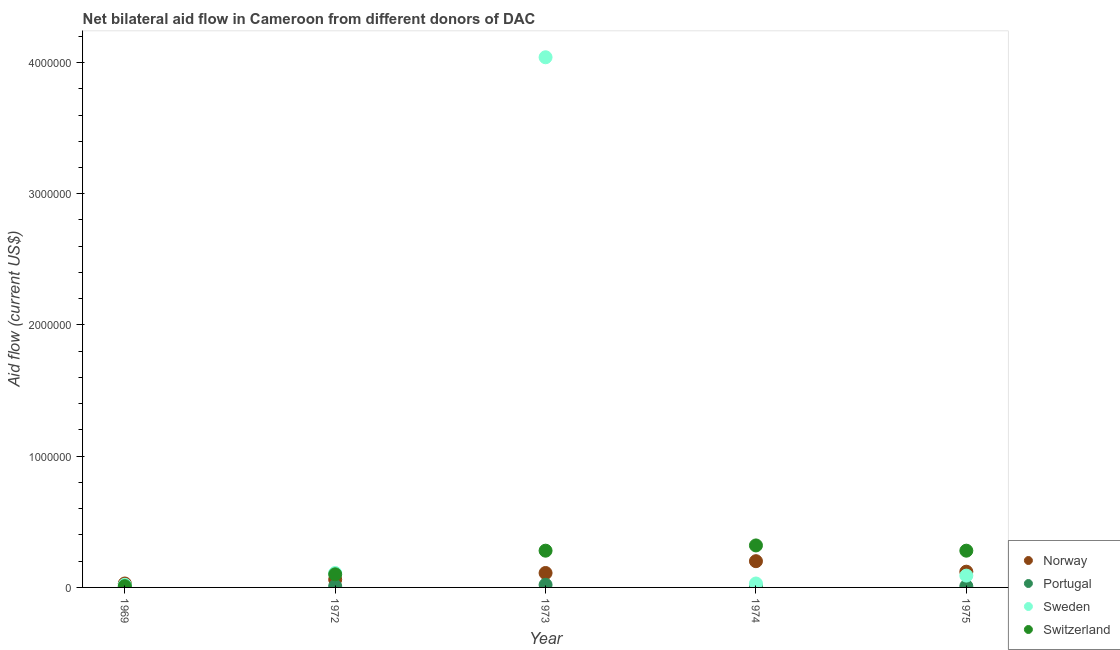How many different coloured dotlines are there?
Your answer should be compact. 4. What is the amount of aid given by norway in 1975?
Keep it short and to the point. 1.20e+05. Across all years, what is the maximum amount of aid given by switzerland?
Provide a short and direct response. 3.20e+05. Across all years, what is the minimum amount of aid given by portugal?
Your answer should be compact. 10000. In which year was the amount of aid given by norway maximum?
Ensure brevity in your answer.  1974. In which year was the amount of aid given by sweden minimum?
Give a very brief answer. 1969. What is the total amount of aid given by sweden in the graph?
Give a very brief answer. 4.29e+06. What is the difference between the amount of aid given by switzerland in 1969 and that in 1974?
Make the answer very short. -3.10e+05. What is the difference between the amount of aid given by sweden in 1975 and the amount of aid given by switzerland in 1972?
Offer a very short reply. -10000. What is the average amount of aid given by norway per year?
Ensure brevity in your answer.  1.04e+05. In the year 1969, what is the difference between the amount of aid given by portugal and amount of aid given by sweden?
Give a very brief answer. -10000. In how many years, is the amount of aid given by sweden greater than 2600000 US$?
Provide a succinct answer. 1. What is the ratio of the amount of aid given by sweden in 1969 to that in 1973?
Your answer should be compact. 0. Is the amount of aid given by portugal in 1972 less than that in 1975?
Your response must be concise. No. What is the difference between the highest and the lowest amount of aid given by portugal?
Offer a terse response. 10000. In how many years, is the amount of aid given by switzerland greater than the average amount of aid given by switzerland taken over all years?
Offer a very short reply. 3. Is the sum of the amount of aid given by portugal in 1972 and 1973 greater than the maximum amount of aid given by sweden across all years?
Ensure brevity in your answer.  No. Is the amount of aid given by switzerland strictly less than the amount of aid given by sweden over the years?
Offer a terse response. No. Does the graph contain grids?
Make the answer very short. No. How many legend labels are there?
Ensure brevity in your answer.  4. How are the legend labels stacked?
Your answer should be very brief. Vertical. What is the title of the graph?
Provide a succinct answer. Net bilateral aid flow in Cameroon from different donors of DAC. Does "Macroeconomic management" appear as one of the legend labels in the graph?
Offer a terse response. No. What is the label or title of the Y-axis?
Your response must be concise. Aid flow (current US$). What is the Aid flow (current US$) in Norway in 1972?
Your answer should be very brief. 6.00e+04. What is the Aid flow (current US$) in Sweden in 1973?
Your answer should be compact. 4.04e+06. What is the Aid flow (current US$) in Switzerland in 1974?
Give a very brief answer. 3.20e+05. What is the Aid flow (current US$) of Portugal in 1975?
Your answer should be compact. 10000. What is the Aid flow (current US$) of Sweden in 1975?
Your answer should be very brief. 9.00e+04. Across all years, what is the maximum Aid flow (current US$) of Norway?
Keep it short and to the point. 2.00e+05. Across all years, what is the maximum Aid flow (current US$) of Sweden?
Provide a short and direct response. 4.04e+06. Across all years, what is the maximum Aid flow (current US$) in Switzerland?
Your answer should be compact. 3.20e+05. Across all years, what is the minimum Aid flow (current US$) in Norway?
Your response must be concise. 3.00e+04. Across all years, what is the minimum Aid flow (current US$) in Switzerland?
Ensure brevity in your answer.  10000. What is the total Aid flow (current US$) in Norway in the graph?
Keep it short and to the point. 5.20e+05. What is the total Aid flow (current US$) in Sweden in the graph?
Your response must be concise. 4.29e+06. What is the total Aid flow (current US$) of Switzerland in the graph?
Ensure brevity in your answer.  9.90e+05. What is the difference between the Aid flow (current US$) in Norway in 1969 and that in 1972?
Your answer should be compact. -3.00e+04. What is the difference between the Aid flow (current US$) of Portugal in 1969 and that in 1972?
Ensure brevity in your answer.  0. What is the difference between the Aid flow (current US$) of Sweden in 1969 and that in 1972?
Ensure brevity in your answer.  -9.00e+04. What is the difference between the Aid flow (current US$) in Norway in 1969 and that in 1973?
Offer a very short reply. -8.00e+04. What is the difference between the Aid flow (current US$) in Sweden in 1969 and that in 1973?
Ensure brevity in your answer.  -4.02e+06. What is the difference between the Aid flow (current US$) in Switzerland in 1969 and that in 1974?
Your answer should be very brief. -3.10e+05. What is the difference between the Aid flow (current US$) in Portugal in 1969 and that in 1975?
Provide a short and direct response. 0. What is the difference between the Aid flow (current US$) in Norway in 1972 and that in 1973?
Your answer should be compact. -5.00e+04. What is the difference between the Aid flow (current US$) in Sweden in 1972 and that in 1973?
Keep it short and to the point. -3.93e+06. What is the difference between the Aid flow (current US$) in Switzerland in 1972 and that in 1973?
Your response must be concise. -1.80e+05. What is the difference between the Aid flow (current US$) in Portugal in 1972 and that in 1974?
Give a very brief answer. 0. What is the difference between the Aid flow (current US$) of Sweden in 1972 and that in 1974?
Your answer should be very brief. 8.00e+04. What is the difference between the Aid flow (current US$) in Switzerland in 1972 and that in 1974?
Offer a terse response. -2.20e+05. What is the difference between the Aid flow (current US$) of Norway in 1973 and that in 1974?
Give a very brief answer. -9.00e+04. What is the difference between the Aid flow (current US$) in Sweden in 1973 and that in 1974?
Your answer should be very brief. 4.01e+06. What is the difference between the Aid flow (current US$) of Portugal in 1973 and that in 1975?
Keep it short and to the point. 10000. What is the difference between the Aid flow (current US$) of Sweden in 1973 and that in 1975?
Your response must be concise. 3.95e+06. What is the difference between the Aid flow (current US$) in Sweden in 1974 and that in 1975?
Provide a succinct answer. -6.00e+04. What is the difference between the Aid flow (current US$) of Norway in 1969 and the Aid flow (current US$) of Sweden in 1972?
Keep it short and to the point. -8.00e+04. What is the difference between the Aid flow (current US$) of Norway in 1969 and the Aid flow (current US$) of Switzerland in 1972?
Provide a succinct answer. -7.00e+04. What is the difference between the Aid flow (current US$) of Norway in 1969 and the Aid flow (current US$) of Sweden in 1973?
Provide a succinct answer. -4.01e+06. What is the difference between the Aid flow (current US$) in Norway in 1969 and the Aid flow (current US$) in Switzerland in 1973?
Your response must be concise. -2.50e+05. What is the difference between the Aid flow (current US$) in Portugal in 1969 and the Aid flow (current US$) in Sweden in 1973?
Keep it short and to the point. -4.03e+06. What is the difference between the Aid flow (current US$) in Norway in 1969 and the Aid flow (current US$) in Portugal in 1974?
Keep it short and to the point. 2.00e+04. What is the difference between the Aid flow (current US$) in Norway in 1969 and the Aid flow (current US$) in Sweden in 1974?
Give a very brief answer. 0. What is the difference between the Aid flow (current US$) of Portugal in 1969 and the Aid flow (current US$) of Switzerland in 1974?
Provide a succinct answer. -3.10e+05. What is the difference between the Aid flow (current US$) in Sweden in 1969 and the Aid flow (current US$) in Switzerland in 1974?
Provide a short and direct response. -3.00e+05. What is the difference between the Aid flow (current US$) in Norway in 1969 and the Aid flow (current US$) in Switzerland in 1975?
Offer a very short reply. -2.50e+05. What is the difference between the Aid flow (current US$) in Portugal in 1969 and the Aid flow (current US$) in Sweden in 1975?
Your response must be concise. -8.00e+04. What is the difference between the Aid flow (current US$) in Portugal in 1969 and the Aid flow (current US$) in Switzerland in 1975?
Offer a very short reply. -2.70e+05. What is the difference between the Aid flow (current US$) in Sweden in 1969 and the Aid flow (current US$) in Switzerland in 1975?
Make the answer very short. -2.60e+05. What is the difference between the Aid flow (current US$) of Norway in 1972 and the Aid flow (current US$) of Sweden in 1973?
Keep it short and to the point. -3.98e+06. What is the difference between the Aid flow (current US$) of Norway in 1972 and the Aid flow (current US$) of Switzerland in 1973?
Provide a succinct answer. -2.20e+05. What is the difference between the Aid flow (current US$) of Portugal in 1972 and the Aid flow (current US$) of Sweden in 1973?
Give a very brief answer. -4.03e+06. What is the difference between the Aid flow (current US$) of Portugal in 1972 and the Aid flow (current US$) of Switzerland in 1973?
Offer a terse response. -2.70e+05. What is the difference between the Aid flow (current US$) in Norway in 1972 and the Aid flow (current US$) in Sweden in 1974?
Ensure brevity in your answer.  3.00e+04. What is the difference between the Aid flow (current US$) of Norway in 1972 and the Aid flow (current US$) of Switzerland in 1974?
Provide a succinct answer. -2.60e+05. What is the difference between the Aid flow (current US$) in Portugal in 1972 and the Aid flow (current US$) in Switzerland in 1974?
Your response must be concise. -3.10e+05. What is the difference between the Aid flow (current US$) in Portugal in 1972 and the Aid flow (current US$) in Sweden in 1975?
Make the answer very short. -8.00e+04. What is the difference between the Aid flow (current US$) in Sweden in 1972 and the Aid flow (current US$) in Switzerland in 1975?
Provide a succinct answer. -1.70e+05. What is the difference between the Aid flow (current US$) in Sweden in 1973 and the Aid flow (current US$) in Switzerland in 1974?
Your answer should be compact. 3.72e+06. What is the difference between the Aid flow (current US$) in Portugal in 1973 and the Aid flow (current US$) in Switzerland in 1975?
Give a very brief answer. -2.60e+05. What is the difference between the Aid flow (current US$) of Sweden in 1973 and the Aid flow (current US$) of Switzerland in 1975?
Provide a succinct answer. 3.76e+06. What is the difference between the Aid flow (current US$) in Norway in 1974 and the Aid flow (current US$) in Portugal in 1975?
Provide a succinct answer. 1.90e+05. What is the difference between the Aid flow (current US$) in Norway in 1974 and the Aid flow (current US$) in Switzerland in 1975?
Your answer should be very brief. -8.00e+04. What is the difference between the Aid flow (current US$) in Portugal in 1974 and the Aid flow (current US$) in Sweden in 1975?
Provide a short and direct response. -8.00e+04. What is the difference between the Aid flow (current US$) in Portugal in 1974 and the Aid flow (current US$) in Switzerland in 1975?
Provide a short and direct response. -2.70e+05. What is the average Aid flow (current US$) of Norway per year?
Your answer should be very brief. 1.04e+05. What is the average Aid flow (current US$) of Portugal per year?
Your answer should be very brief. 1.20e+04. What is the average Aid flow (current US$) in Sweden per year?
Offer a very short reply. 8.58e+05. What is the average Aid flow (current US$) of Switzerland per year?
Keep it short and to the point. 1.98e+05. In the year 1969, what is the difference between the Aid flow (current US$) in Norway and Aid flow (current US$) in Portugal?
Your answer should be compact. 2.00e+04. In the year 1969, what is the difference between the Aid flow (current US$) of Portugal and Aid flow (current US$) of Sweden?
Provide a succinct answer. -10000. In the year 1969, what is the difference between the Aid flow (current US$) in Portugal and Aid flow (current US$) in Switzerland?
Keep it short and to the point. 0. In the year 1969, what is the difference between the Aid flow (current US$) in Sweden and Aid flow (current US$) in Switzerland?
Keep it short and to the point. 10000. In the year 1972, what is the difference between the Aid flow (current US$) of Norway and Aid flow (current US$) of Portugal?
Your response must be concise. 5.00e+04. In the year 1972, what is the difference between the Aid flow (current US$) of Norway and Aid flow (current US$) of Switzerland?
Your answer should be very brief. -4.00e+04. In the year 1972, what is the difference between the Aid flow (current US$) of Portugal and Aid flow (current US$) of Sweden?
Provide a short and direct response. -1.00e+05. In the year 1972, what is the difference between the Aid flow (current US$) of Portugal and Aid flow (current US$) of Switzerland?
Provide a short and direct response. -9.00e+04. In the year 1973, what is the difference between the Aid flow (current US$) in Norway and Aid flow (current US$) in Portugal?
Offer a terse response. 9.00e+04. In the year 1973, what is the difference between the Aid flow (current US$) of Norway and Aid flow (current US$) of Sweden?
Make the answer very short. -3.93e+06. In the year 1973, what is the difference between the Aid flow (current US$) in Portugal and Aid flow (current US$) in Sweden?
Make the answer very short. -4.02e+06. In the year 1973, what is the difference between the Aid flow (current US$) in Portugal and Aid flow (current US$) in Switzerland?
Offer a terse response. -2.60e+05. In the year 1973, what is the difference between the Aid flow (current US$) of Sweden and Aid flow (current US$) of Switzerland?
Give a very brief answer. 3.76e+06. In the year 1974, what is the difference between the Aid flow (current US$) in Norway and Aid flow (current US$) in Portugal?
Keep it short and to the point. 1.90e+05. In the year 1974, what is the difference between the Aid flow (current US$) of Portugal and Aid flow (current US$) of Sweden?
Ensure brevity in your answer.  -2.00e+04. In the year 1974, what is the difference between the Aid flow (current US$) in Portugal and Aid flow (current US$) in Switzerland?
Your answer should be compact. -3.10e+05. In the year 1974, what is the difference between the Aid flow (current US$) of Sweden and Aid flow (current US$) of Switzerland?
Your response must be concise. -2.90e+05. In the year 1975, what is the difference between the Aid flow (current US$) in Norway and Aid flow (current US$) in Portugal?
Your answer should be compact. 1.10e+05. In the year 1975, what is the difference between the Aid flow (current US$) in Norway and Aid flow (current US$) in Sweden?
Ensure brevity in your answer.  3.00e+04. In the year 1975, what is the difference between the Aid flow (current US$) in Sweden and Aid flow (current US$) in Switzerland?
Offer a very short reply. -1.90e+05. What is the ratio of the Aid flow (current US$) of Sweden in 1969 to that in 1972?
Offer a terse response. 0.18. What is the ratio of the Aid flow (current US$) of Switzerland in 1969 to that in 1972?
Your response must be concise. 0.1. What is the ratio of the Aid flow (current US$) in Norway in 1969 to that in 1973?
Ensure brevity in your answer.  0.27. What is the ratio of the Aid flow (current US$) of Portugal in 1969 to that in 1973?
Your answer should be very brief. 0.5. What is the ratio of the Aid flow (current US$) in Sweden in 1969 to that in 1973?
Give a very brief answer. 0.01. What is the ratio of the Aid flow (current US$) of Switzerland in 1969 to that in 1973?
Your response must be concise. 0.04. What is the ratio of the Aid flow (current US$) in Norway in 1969 to that in 1974?
Your response must be concise. 0.15. What is the ratio of the Aid flow (current US$) in Switzerland in 1969 to that in 1974?
Provide a succinct answer. 0.03. What is the ratio of the Aid flow (current US$) in Portugal in 1969 to that in 1975?
Offer a very short reply. 1. What is the ratio of the Aid flow (current US$) in Sweden in 1969 to that in 1975?
Offer a terse response. 0.22. What is the ratio of the Aid flow (current US$) in Switzerland in 1969 to that in 1975?
Make the answer very short. 0.04. What is the ratio of the Aid flow (current US$) of Norway in 1972 to that in 1973?
Keep it short and to the point. 0.55. What is the ratio of the Aid flow (current US$) in Portugal in 1972 to that in 1973?
Provide a short and direct response. 0.5. What is the ratio of the Aid flow (current US$) in Sweden in 1972 to that in 1973?
Provide a succinct answer. 0.03. What is the ratio of the Aid flow (current US$) of Switzerland in 1972 to that in 1973?
Offer a terse response. 0.36. What is the ratio of the Aid flow (current US$) of Norway in 1972 to that in 1974?
Keep it short and to the point. 0.3. What is the ratio of the Aid flow (current US$) of Sweden in 1972 to that in 1974?
Provide a short and direct response. 3.67. What is the ratio of the Aid flow (current US$) of Switzerland in 1972 to that in 1974?
Offer a terse response. 0.31. What is the ratio of the Aid flow (current US$) in Portugal in 1972 to that in 1975?
Give a very brief answer. 1. What is the ratio of the Aid flow (current US$) of Sweden in 1972 to that in 1975?
Your answer should be compact. 1.22. What is the ratio of the Aid flow (current US$) of Switzerland in 1972 to that in 1975?
Offer a very short reply. 0.36. What is the ratio of the Aid flow (current US$) of Norway in 1973 to that in 1974?
Your answer should be very brief. 0.55. What is the ratio of the Aid flow (current US$) of Portugal in 1973 to that in 1974?
Keep it short and to the point. 2. What is the ratio of the Aid flow (current US$) of Sweden in 1973 to that in 1974?
Make the answer very short. 134.67. What is the ratio of the Aid flow (current US$) in Switzerland in 1973 to that in 1974?
Your answer should be very brief. 0.88. What is the ratio of the Aid flow (current US$) in Norway in 1973 to that in 1975?
Your answer should be very brief. 0.92. What is the ratio of the Aid flow (current US$) of Sweden in 1973 to that in 1975?
Ensure brevity in your answer.  44.89. What is the ratio of the Aid flow (current US$) in Portugal in 1974 to that in 1975?
Your answer should be compact. 1. What is the ratio of the Aid flow (current US$) in Sweden in 1974 to that in 1975?
Your response must be concise. 0.33. What is the ratio of the Aid flow (current US$) in Switzerland in 1974 to that in 1975?
Provide a succinct answer. 1.14. What is the difference between the highest and the second highest Aid flow (current US$) in Sweden?
Offer a very short reply. 3.93e+06. What is the difference between the highest and the second highest Aid flow (current US$) in Switzerland?
Provide a succinct answer. 4.00e+04. What is the difference between the highest and the lowest Aid flow (current US$) of Sweden?
Give a very brief answer. 4.02e+06. What is the difference between the highest and the lowest Aid flow (current US$) of Switzerland?
Provide a succinct answer. 3.10e+05. 